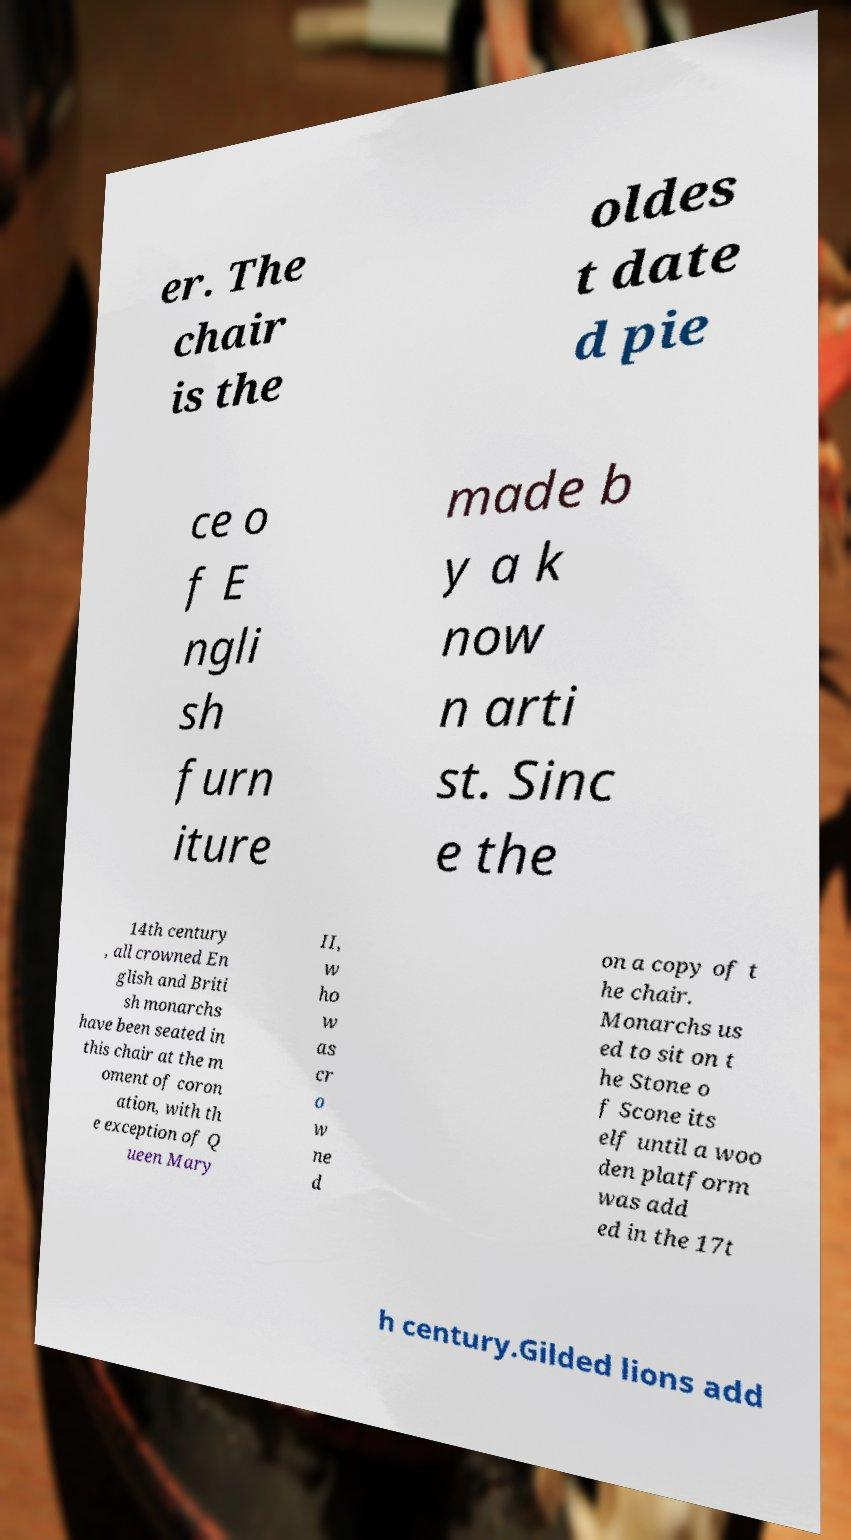Can you read and provide the text displayed in the image?This photo seems to have some interesting text. Can you extract and type it out for me? er. The chair is the oldes t date d pie ce o f E ngli sh furn iture made b y a k now n arti st. Sinc e the 14th century , all crowned En glish and Briti sh monarchs have been seated in this chair at the m oment of coron ation, with th e exception of Q ueen Mary II, w ho w as cr o w ne d on a copy of t he chair. Monarchs us ed to sit on t he Stone o f Scone its elf until a woo den platform was add ed in the 17t h century.Gilded lions add 